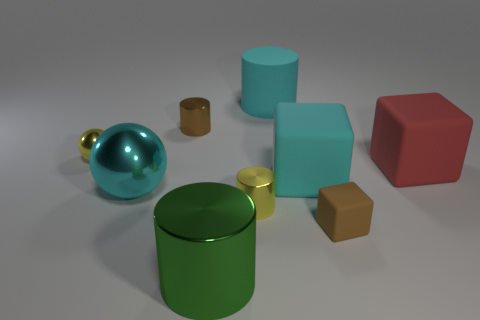Are there any yellow metallic balls?
Offer a very short reply. Yes. What number of other things are there of the same size as the green cylinder?
Offer a terse response. 4. Do the big sphere and the big matte cube that is left of the red rubber object have the same color?
Provide a short and direct response. Yes. How many objects are either big cylinders or tiny metal cylinders?
Ensure brevity in your answer.  4. Are there any other things that are the same color as the small block?
Offer a very short reply. Yes. Do the large green object and the yellow thing that is right of the large shiny sphere have the same material?
Offer a terse response. Yes. The cyan matte thing that is in front of the object that is to the right of the tiny brown matte thing is what shape?
Your answer should be compact. Cube. There is a large cyan object that is both to the right of the brown cylinder and in front of the small ball; what is its shape?
Keep it short and to the point. Cube. What number of things are yellow balls or matte things that are to the right of the big cyan matte cylinder?
Give a very brief answer. 4. What is the material of the big cyan thing that is the same shape as the tiny brown metal object?
Your answer should be compact. Rubber. 